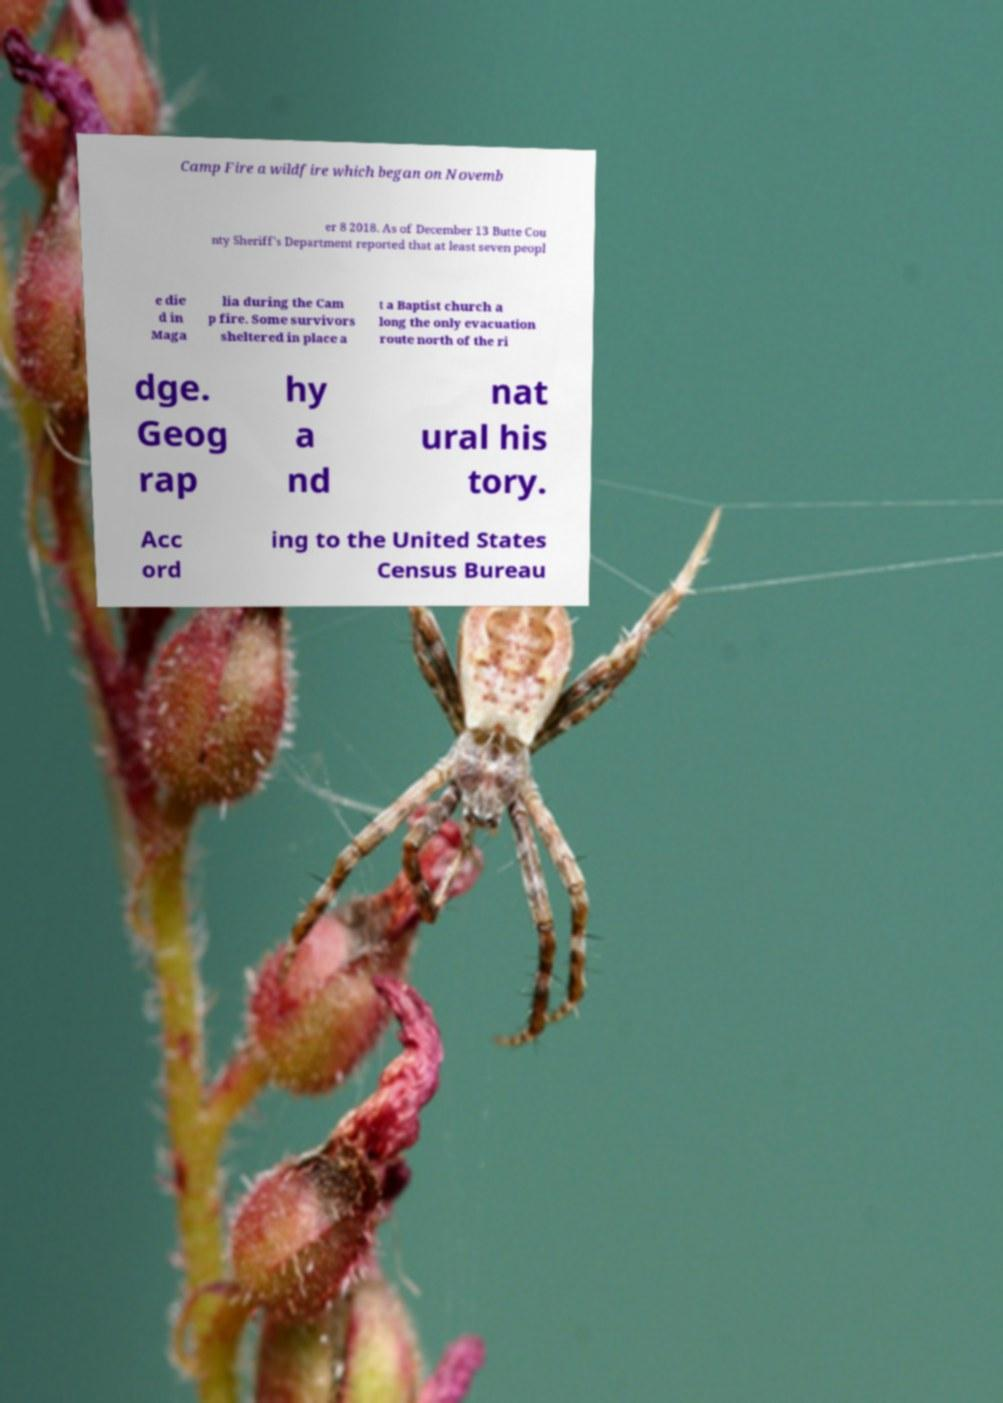What messages or text are displayed in this image? I need them in a readable, typed format. Camp Fire a wildfire which began on Novemb er 8 2018. As of December 13 Butte Cou nty Sheriff's Department reported that at least seven peopl e die d in Maga lia during the Cam p fire. Some survivors sheltered in place a t a Baptist church a long the only evacuation route north of the ri dge. Geog rap hy a nd nat ural his tory. Acc ord ing to the United States Census Bureau 